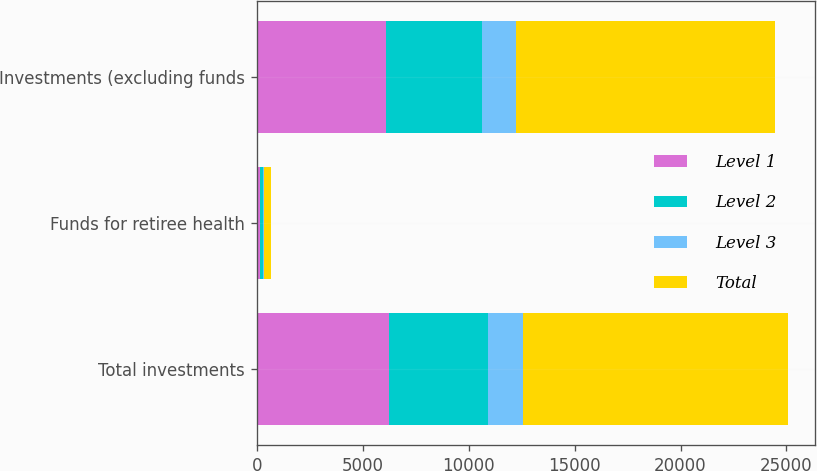<chart> <loc_0><loc_0><loc_500><loc_500><stacked_bar_chart><ecel><fcel>Total investments<fcel>Funds for retiree health<fcel>Investments (excluding funds<nl><fcel>Level 1<fcel>6256<fcel>162<fcel>6094<nl><fcel>Level 2<fcel>4641<fcel>120<fcel>4521<nl><fcel>Level 3<fcel>1651<fcel>43<fcel>1608<nl><fcel>Total<fcel>12548<fcel>325<fcel>12223<nl></chart> 